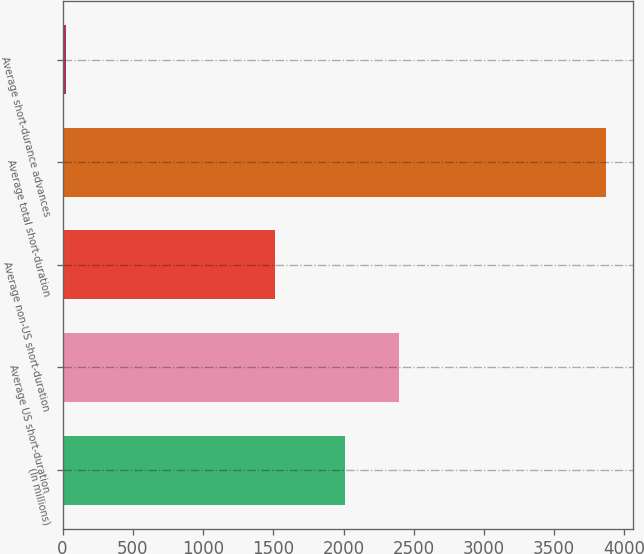Convert chart. <chart><loc_0><loc_0><loc_500><loc_500><bar_chart><fcel>(In millions)<fcel>Average US short-duration<fcel>Average non-US short-duration<fcel>Average total short-duration<fcel>Average short-durance advances<nl><fcel>2014<fcel>2398.3<fcel>1512<fcel>3867<fcel>24<nl></chart> 